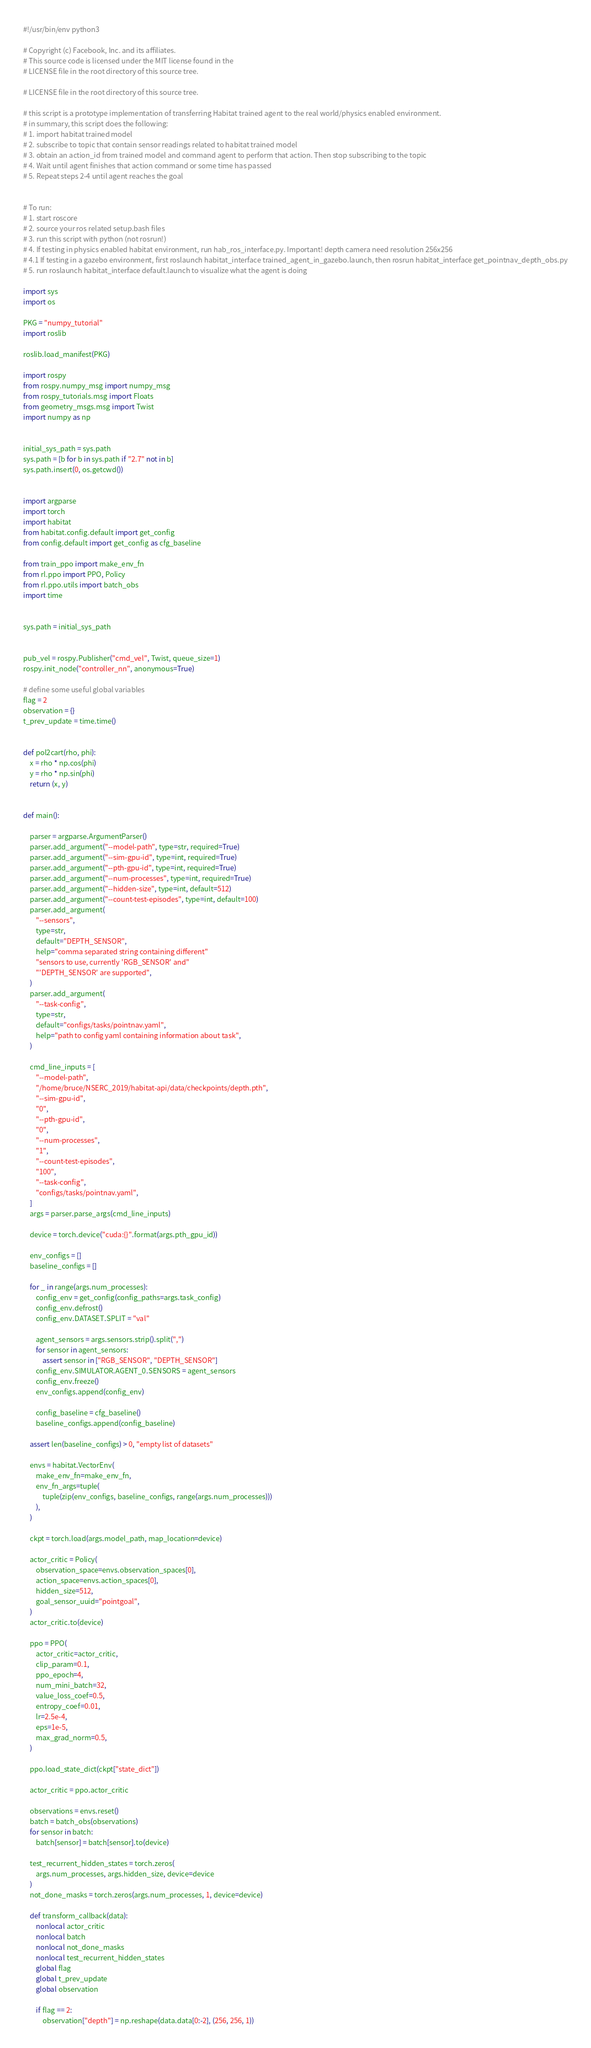<code> <loc_0><loc_0><loc_500><loc_500><_Python_>#!/usr/bin/env python3

# Copyright (c) Facebook, Inc. and its affiliates.
# This source code is licensed under the MIT license found in the
# LICENSE file in the root directory of this source tree.

# LICENSE file in the root directory of this source tree.

# this script is a prototype implementation of transferring Habitat trained agent to the real world/physics enabled environment.
# in summary, this script does the following:
# 1. import habitat trained model
# 2. subscribe to topic that contain sensor readings related to habitat trained model
# 3. obtain an action_id from trained model and command agent to perform that action. Then stop subscribing to the topic
# 4. Wait until agent finishes that action command or some time has passed
# 5. Repeat steps 2-4 until agent reaches the goal


# To run:
# 1. start roscore
# 2. source your ros related setup.bash files
# 3. run this script with python (not rosrun!)
# 4. If testing in physics enabled habitat environment, run hab_ros_interface.py. Important! depth camera need resolution 256x256
# 4.1 If testing in a gazebo environment, first roslaunch habitat_interface trained_agent_in_gazebo.launch, then rosrun habitat_interface get_pointnav_depth_obs.py
# 5. run roslaunch habitat_interface default.launch to visualize what the agent is doing

import sys
import os

PKG = "numpy_tutorial"
import roslib

roslib.load_manifest(PKG)

import rospy
from rospy.numpy_msg import numpy_msg
from rospy_tutorials.msg import Floats
from geometry_msgs.msg import Twist
import numpy as np


initial_sys_path = sys.path
sys.path = [b for b in sys.path if "2.7" not in b]
sys.path.insert(0, os.getcwd())


import argparse
import torch
import habitat
from habitat.config.default import get_config
from config.default import get_config as cfg_baseline

from train_ppo import make_env_fn
from rl.ppo import PPO, Policy
from rl.ppo.utils import batch_obs
import time


sys.path = initial_sys_path


pub_vel = rospy.Publisher("cmd_vel", Twist, queue_size=1)
rospy.init_node("controller_nn", anonymous=True)

# define some useful global variables
flag = 2
observation = {}
t_prev_update = time.time()


def pol2cart(rho, phi):
    x = rho * np.cos(phi)
    y = rho * np.sin(phi)
    return (x, y)


def main():

    parser = argparse.ArgumentParser()
    parser.add_argument("--model-path", type=str, required=True)
    parser.add_argument("--sim-gpu-id", type=int, required=True)
    parser.add_argument("--pth-gpu-id", type=int, required=True)
    parser.add_argument("--num-processes", type=int, required=True)
    parser.add_argument("--hidden-size", type=int, default=512)
    parser.add_argument("--count-test-episodes", type=int, default=100)
    parser.add_argument(
        "--sensors",
        type=str,
        default="DEPTH_SENSOR",
        help="comma separated string containing different"
        "sensors to use, currently 'RGB_SENSOR' and"
        "'DEPTH_SENSOR' are supported",
    )
    parser.add_argument(
        "--task-config",
        type=str,
        default="configs/tasks/pointnav.yaml",
        help="path to config yaml containing information about task",
    )

    cmd_line_inputs = [
        "--model-path",
        "/home/bruce/NSERC_2019/habitat-api/data/checkpoints/depth.pth",
        "--sim-gpu-id",
        "0",
        "--pth-gpu-id",
        "0",
        "--num-processes",
        "1",
        "--count-test-episodes",
        "100",
        "--task-config",
        "configs/tasks/pointnav.yaml",
    ]
    args = parser.parse_args(cmd_line_inputs)

    device = torch.device("cuda:{}".format(args.pth_gpu_id))

    env_configs = []
    baseline_configs = []

    for _ in range(args.num_processes):
        config_env = get_config(config_paths=args.task_config)
        config_env.defrost()
        config_env.DATASET.SPLIT = "val"

        agent_sensors = args.sensors.strip().split(",")
        for sensor in agent_sensors:
            assert sensor in ["RGB_SENSOR", "DEPTH_SENSOR"]
        config_env.SIMULATOR.AGENT_0.SENSORS = agent_sensors
        config_env.freeze()
        env_configs.append(config_env)

        config_baseline = cfg_baseline()
        baseline_configs.append(config_baseline)

    assert len(baseline_configs) > 0, "empty list of datasets"

    envs = habitat.VectorEnv(
        make_env_fn=make_env_fn,
        env_fn_args=tuple(
            tuple(zip(env_configs, baseline_configs, range(args.num_processes)))
        ),
    )

    ckpt = torch.load(args.model_path, map_location=device)

    actor_critic = Policy(
        observation_space=envs.observation_spaces[0],
        action_space=envs.action_spaces[0],
        hidden_size=512,
        goal_sensor_uuid="pointgoal",
    )
    actor_critic.to(device)

    ppo = PPO(
        actor_critic=actor_critic,
        clip_param=0.1,
        ppo_epoch=4,
        num_mini_batch=32,
        value_loss_coef=0.5,
        entropy_coef=0.01,
        lr=2.5e-4,
        eps=1e-5,
        max_grad_norm=0.5,
    )

    ppo.load_state_dict(ckpt["state_dict"])

    actor_critic = ppo.actor_critic

    observations = envs.reset()
    batch = batch_obs(observations)
    for sensor in batch:
        batch[sensor] = batch[sensor].to(device)

    test_recurrent_hidden_states = torch.zeros(
        args.num_processes, args.hidden_size, device=device
    )
    not_done_masks = torch.zeros(args.num_processes, 1, device=device)

    def transform_callback(data):
        nonlocal actor_critic
        nonlocal batch
        nonlocal not_done_masks
        nonlocal test_recurrent_hidden_states
        global flag
        global t_prev_update
        global observation

        if flag == 2:
            observation["depth"] = np.reshape(data.data[0:-2], (256, 256, 1))</code> 